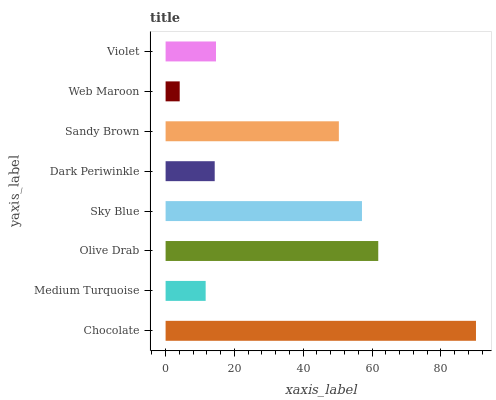Is Web Maroon the minimum?
Answer yes or no. Yes. Is Chocolate the maximum?
Answer yes or no. Yes. Is Medium Turquoise the minimum?
Answer yes or no. No. Is Medium Turquoise the maximum?
Answer yes or no. No. Is Chocolate greater than Medium Turquoise?
Answer yes or no. Yes. Is Medium Turquoise less than Chocolate?
Answer yes or no. Yes. Is Medium Turquoise greater than Chocolate?
Answer yes or no. No. Is Chocolate less than Medium Turquoise?
Answer yes or no. No. Is Sandy Brown the high median?
Answer yes or no. Yes. Is Violet the low median?
Answer yes or no. Yes. Is Sky Blue the high median?
Answer yes or no. No. Is Dark Periwinkle the low median?
Answer yes or no. No. 